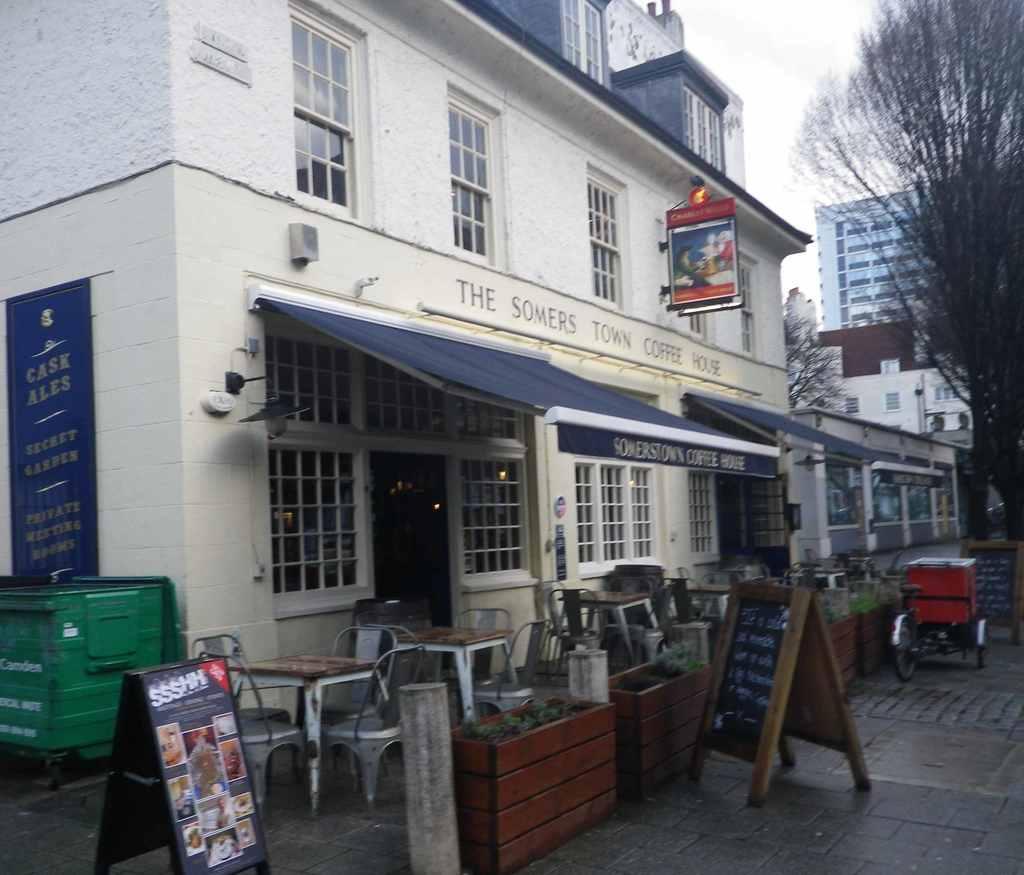Can you describe this image briefly? We can see in the picture that a building, a street and a black board. There are many chairs and tables are placed. There is a tree in front of building and sky above building. 